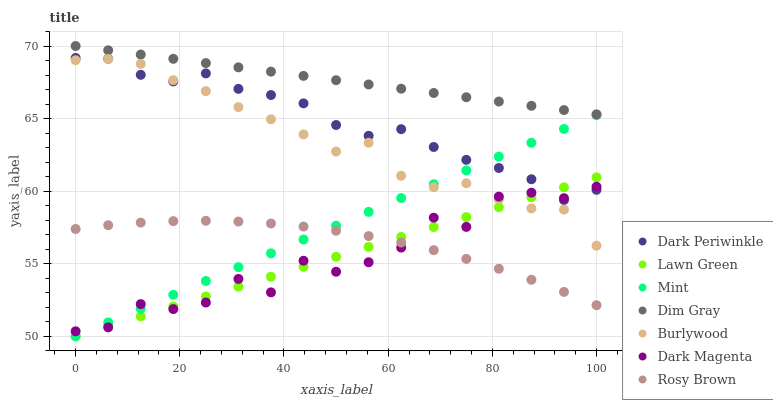Does Dark Magenta have the minimum area under the curve?
Answer yes or no. Yes. Does Dim Gray have the maximum area under the curve?
Answer yes or no. Yes. Does Dim Gray have the minimum area under the curve?
Answer yes or no. No. Does Dark Magenta have the maximum area under the curve?
Answer yes or no. No. Is Lawn Green the smoothest?
Answer yes or no. Yes. Is Dark Magenta the roughest?
Answer yes or no. Yes. Is Dim Gray the smoothest?
Answer yes or no. No. Is Dim Gray the roughest?
Answer yes or no. No. Does Lawn Green have the lowest value?
Answer yes or no. Yes. Does Dark Magenta have the lowest value?
Answer yes or no. No. Does Dim Gray have the highest value?
Answer yes or no. Yes. Does Dark Magenta have the highest value?
Answer yes or no. No. Is Rosy Brown less than Dark Periwinkle?
Answer yes or no. Yes. Is Dim Gray greater than Dark Magenta?
Answer yes or no. Yes. Does Dark Periwinkle intersect Mint?
Answer yes or no. Yes. Is Dark Periwinkle less than Mint?
Answer yes or no. No. Is Dark Periwinkle greater than Mint?
Answer yes or no. No. Does Rosy Brown intersect Dark Periwinkle?
Answer yes or no. No. 